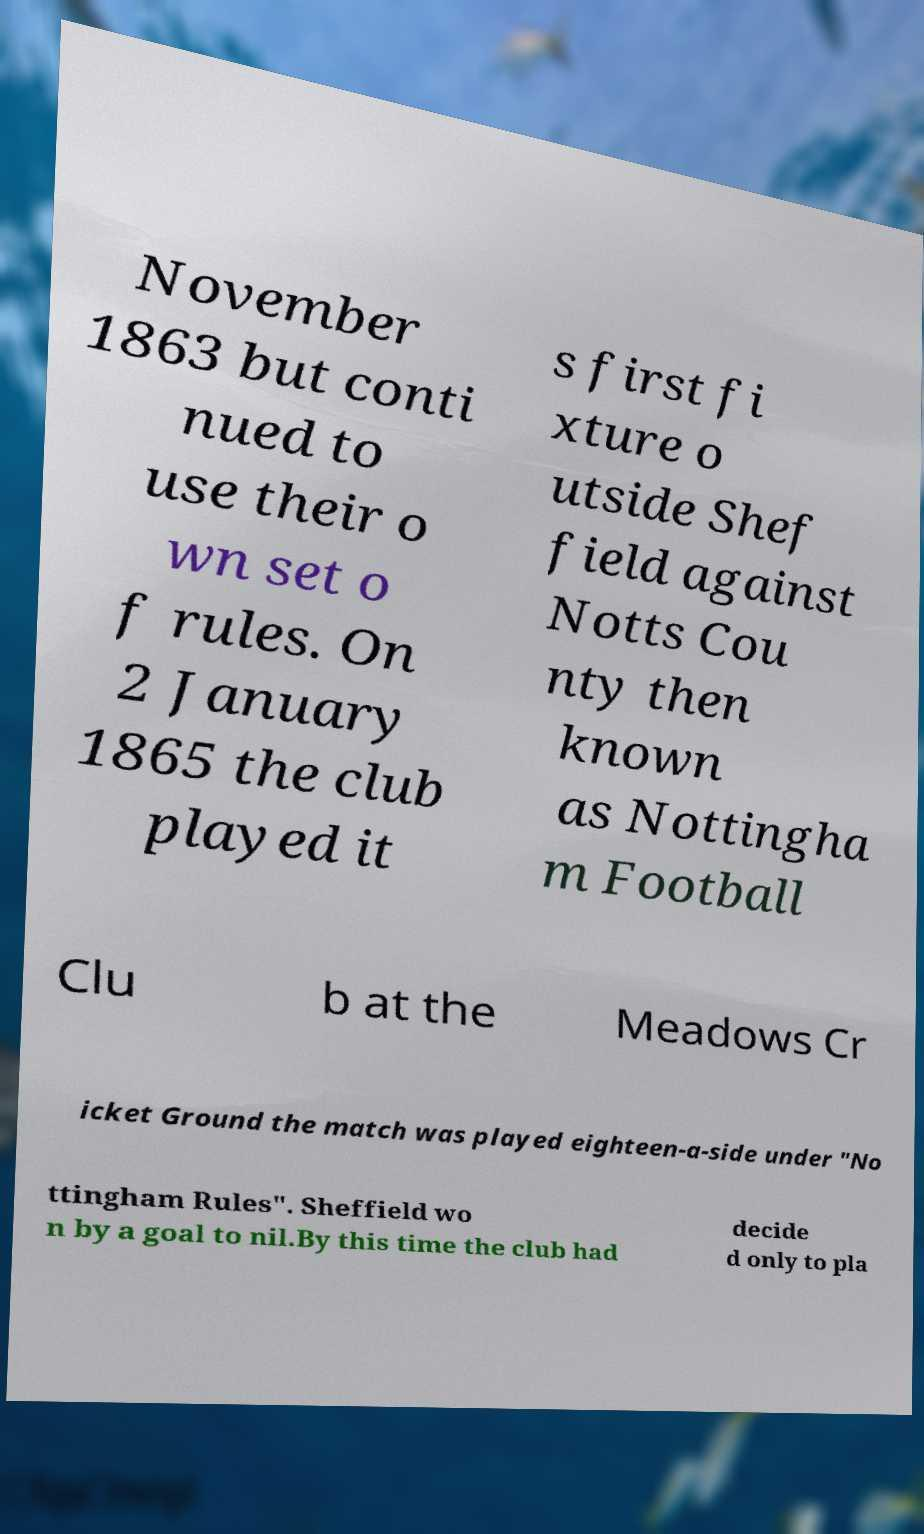Could you extract and type out the text from this image? November 1863 but conti nued to use their o wn set o f rules. On 2 January 1865 the club played it s first fi xture o utside Shef field against Notts Cou nty then known as Nottingha m Football Clu b at the Meadows Cr icket Ground the match was played eighteen-a-side under "No ttingham Rules". Sheffield wo n by a goal to nil.By this time the club had decide d only to pla 